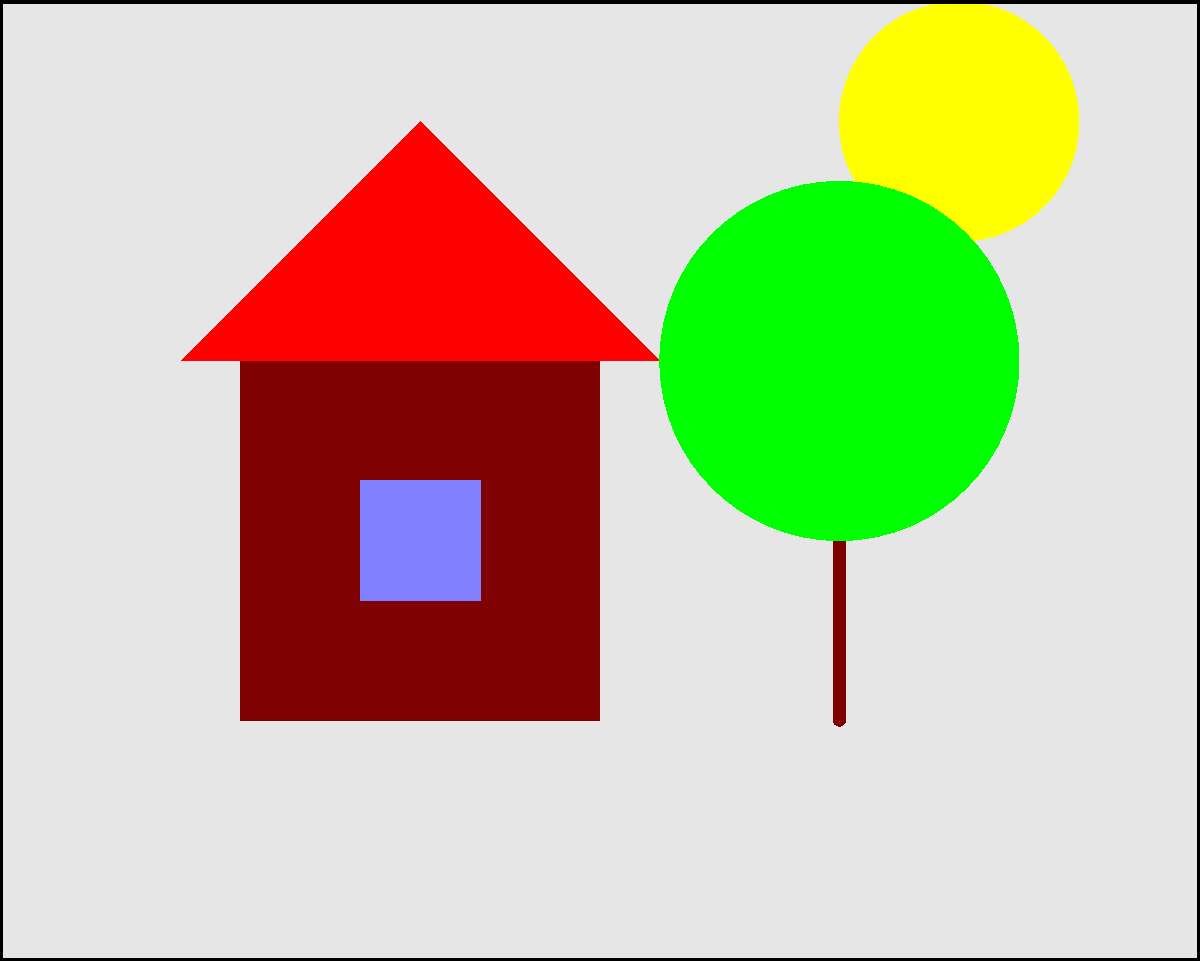You are recreating a simplified version of Ivan Marchuk's "Ukrainian Landscape" using vector tools. Which shape would be most appropriate for creating the sun in this vector illustration? To recreate a simplified version of Ivan Marchuk's "Ukrainian Landscape" using vector tools, we need to consider the basic geometric shapes that can represent various elements in the painting. Let's analyze the steps:

1. Identify the key elements: In a typical Ukrainian landscape, we often see the sun, houses, trees, and fields.

2. Simplify the shapes: For a vector illustration, we need to use basic geometric shapes to represent these elements.

3. Choose the appropriate shape for the sun:
   a) The sun is usually depicted as a circular object in the sky.
   b) In vector graphics, perfect circles are easily created and manipulated.
   c) A circle provides a simple yet effective representation of the sun.

4. Consider alternatives:
   a) A polygon could be used, but it would be less accurate and more complex.
   b) A freeform shape might be too detailed for a simplified version.

5. Implement the solution:
   In vector software, you would typically use the ellipse or circle tool to create a perfect circle for the sun.

Therefore, the most appropriate shape for creating the sun in this vector illustration would be a circle.
Answer: Circle 